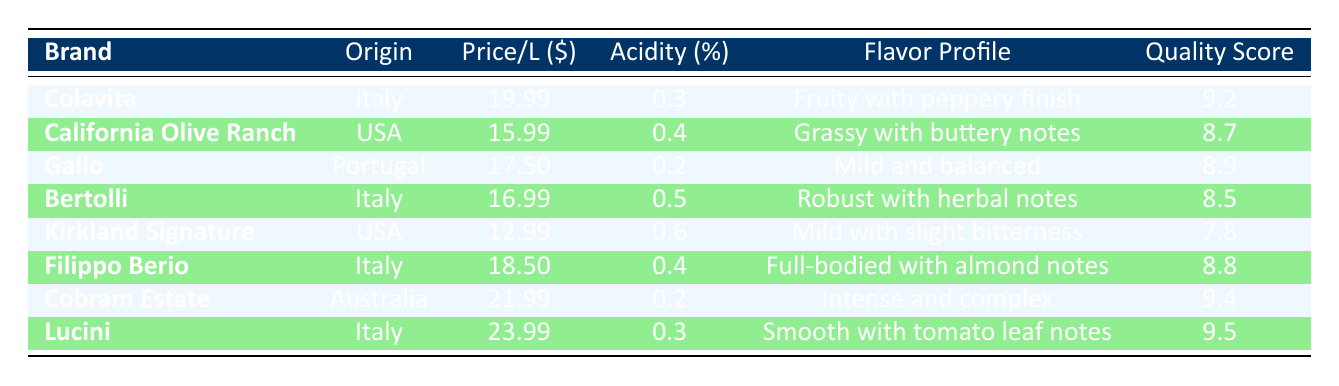What is the highest quality score among the olive oils listed? The table shows the quality scores for each olive oil brand. By examining the scores, I find that Lucini has the highest quality score at 9.5.
Answer: 9.5 What is the price per liter of Kirkland Signature olive oil? The table lists Kirkland Signature under the USA origin olive oils, where the price per liter is clearly marked as 12.99.
Answer: 12.99 Which imported olive oil has the lowest acidity? By reviewing the acidity levels in the table, I see that both Gallo and Cobram Estate have the lowest acidity at 0.2. However, Gallo is an imported oil as it originates from Portugal.
Answer: 0.2 What is the average price per liter of the Italian olive oils listed? The Italian olive oils in the table are Colavita, Bertolli, Filippo Berio, and Lucini. Their prices are 19.99, 16.99, 18.50, and 23.99, respectively. The sum of these prices is 79.47. There are 4 Italian olive oils, so the average price is 79.47/4 = 19.87.
Answer: 19.87 Is the quality score of Cobram Estate higher than that of California Olive Ranch? Cobram Estate has a quality score of 9.4, while California Olive Ranch has a score of 8.7. Since 9.4 is greater than 8.7, the answer is yes.
Answer: Yes What is the difference in quality score between Lucini and Kirkland Signature? Lucini has a quality score of 9.5, and Kirkland Signature has a score of 7.8. To find the difference, I subtract 7.8 from 9.5, which yields 1.7.
Answer: 1.7 Are all imported olive oils priced above 15 dollars per liter? Checking the table, the only imported olive oils are Colavita, Gallo, Cobram Estate, and Lucini. Their prices are 19.99, 17.50, 21.99, and 23.99, respectively, all of which are above 15. Therefore, the answer is yes.
Answer: Yes Which fruity olive oil has the highest quality score, and what is that score? From the table, Colavita has a flavor profile marked as "Fruity with peppery finish" and a quality score of 9.2. The olive oil with the highest flavor profile should be checked among those that are fruity, and since Colavita is the one listed as 'fruity', the highest score is 9.2.
Answer: 9.2 What is the quality score of the lowest priced olive oil? From the table, Kirkland Signature is the lowest priced olive oil at 12.99. Its quality score is 7.8, which I can directly retrieve from the entries corresponding to the pricing.
Answer: 7.8 